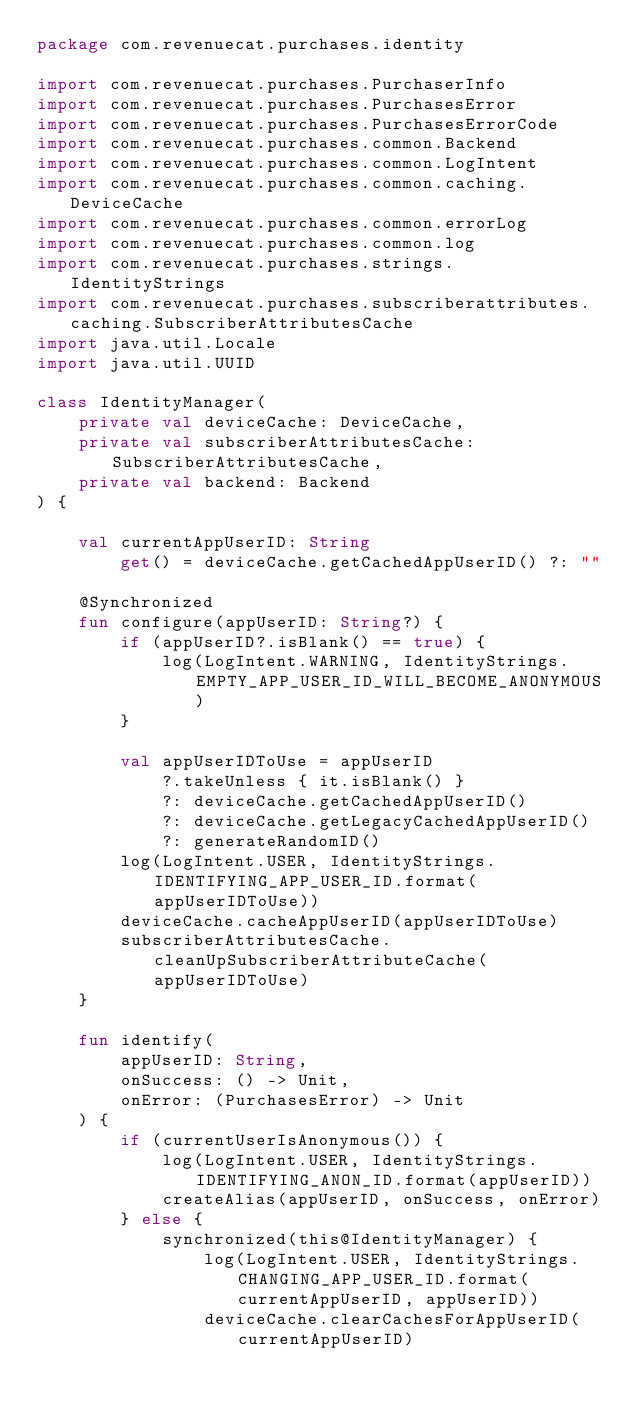<code> <loc_0><loc_0><loc_500><loc_500><_Kotlin_>package com.revenuecat.purchases.identity

import com.revenuecat.purchases.PurchaserInfo
import com.revenuecat.purchases.PurchasesError
import com.revenuecat.purchases.PurchasesErrorCode
import com.revenuecat.purchases.common.Backend
import com.revenuecat.purchases.common.LogIntent
import com.revenuecat.purchases.common.caching.DeviceCache
import com.revenuecat.purchases.common.errorLog
import com.revenuecat.purchases.common.log
import com.revenuecat.purchases.strings.IdentityStrings
import com.revenuecat.purchases.subscriberattributes.caching.SubscriberAttributesCache
import java.util.Locale
import java.util.UUID

class IdentityManager(
    private val deviceCache: DeviceCache,
    private val subscriberAttributesCache: SubscriberAttributesCache,
    private val backend: Backend
) {

    val currentAppUserID: String
        get() = deviceCache.getCachedAppUserID() ?: ""

    @Synchronized
    fun configure(appUserID: String?) {
        if (appUserID?.isBlank() == true) {
            log(LogIntent.WARNING, IdentityStrings.EMPTY_APP_USER_ID_WILL_BECOME_ANONYMOUS)
        }

        val appUserIDToUse = appUserID
            ?.takeUnless { it.isBlank() }
            ?: deviceCache.getCachedAppUserID()
            ?: deviceCache.getLegacyCachedAppUserID()
            ?: generateRandomID()
        log(LogIntent.USER, IdentityStrings.IDENTIFYING_APP_USER_ID.format(appUserIDToUse))
        deviceCache.cacheAppUserID(appUserIDToUse)
        subscriberAttributesCache.cleanUpSubscriberAttributeCache(appUserIDToUse)
    }

    fun identify(
        appUserID: String,
        onSuccess: () -> Unit,
        onError: (PurchasesError) -> Unit
    ) {
        if (currentUserIsAnonymous()) {
            log(LogIntent.USER, IdentityStrings.IDENTIFYING_ANON_ID.format(appUserID))
            createAlias(appUserID, onSuccess, onError)
        } else {
            synchronized(this@IdentityManager) {
                log(LogIntent.USER, IdentityStrings.CHANGING_APP_USER_ID.format(currentAppUserID, appUserID))
                deviceCache.clearCachesForAppUserID(currentAppUserID)</code> 